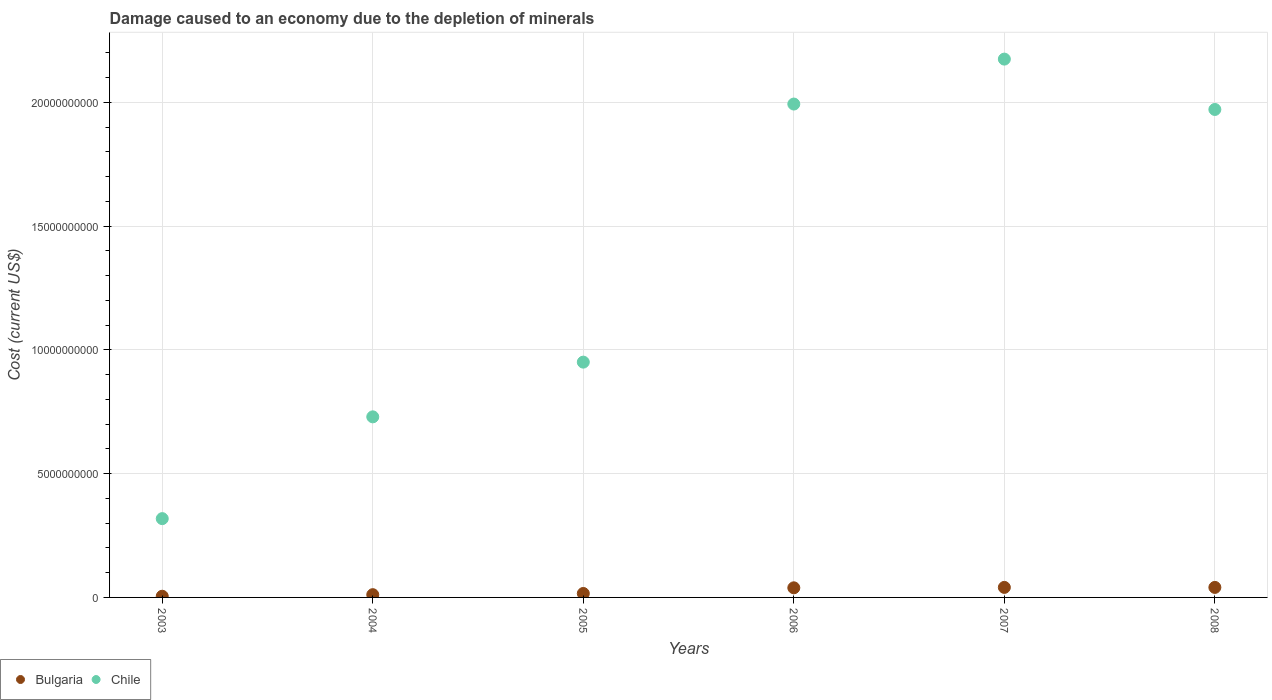Is the number of dotlines equal to the number of legend labels?
Give a very brief answer. Yes. What is the cost of damage caused due to the depletion of minerals in Bulgaria in 2006?
Provide a succinct answer. 3.88e+08. Across all years, what is the maximum cost of damage caused due to the depletion of minerals in Chile?
Provide a succinct answer. 2.18e+1. Across all years, what is the minimum cost of damage caused due to the depletion of minerals in Bulgaria?
Offer a terse response. 4.79e+07. In which year was the cost of damage caused due to the depletion of minerals in Chile minimum?
Keep it short and to the point. 2003. What is the total cost of damage caused due to the depletion of minerals in Bulgaria in the graph?
Your answer should be very brief. 1.52e+09. What is the difference between the cost of damage caused due to the depletion of minerals in Chile in 2004 and that in 2006?
Ensure brevity in your answer.  -1.26e+1. What is the difference between the cost of damage caused due to the depletion of minerals in Bulgaria in 2003 and the cost of damage caused due to the depletion of minerals in Chile in 2007?
Keep it short and to the point. -2.17e+1. What is the average cost of damage caused due to the depletion of minerals in Chile per year?
Your response must be concise. 1.36e+1. In the year 2007, what is the difference between the cost of damage caused due to the depletion of minerals in Bulgaria and cost of damage caused due to the depletion of minerals in Chile?
Provide a short and direct response. -2.13e+1. In how many years, is the cost of damage caused due to the depletion of minerals in Chile greater than 10000000000 US$?
Your answer should be very brief. 3. What is the ratio of the cost of damage caused due to the depletion of minerals in Chile in 2005 to that in 2006?
Give a very brief answer. 0.48. Is the cost of damage caused due to the depletion of minerals in Bulgaria in 2006 less than that in 2008?
Your response must be concise. Yes. What is the difference between the highest and the second highest cost of damage caused due to the depletion of minerals in Chile?
Keep it short and to the point. 1.82e+09. What is the difference between the highest and the lowest cost of damage caused due to the depletion of minerals in Chile?
Your answer should be very brief. 1.86e+1. In how many years, is the cost of damage caused due to the depletion of minerals in Bulgaria greater than the average cost of damage caused due to the depletion of minerals in Bulgaria taken over all years?
Your answer should be very brief. 3. Is the sum of the cost of damage caused due to the depletion of minerals in Bulgaria in 2003 and 2005 greater than the maximum cost of damage caused due to the depletion of minerals in Chile across all years?
Your response must be concise. No. What is the difference between two consecutive major ticks on the Y-axis?
Give a very brief answer. 5.00e+09. Are the values on the major ticks of Y-axis written in scientific E-notation?
Your answer should be compact. No. Does the graph contain any zero values?
Provide a short and direct response. No. Does the graph contain grids?
Your answer should be compact. Yes. Where does the legend appear in the graph?
Your response must be concise. Bottom left. How are the legend labels stacked?
Offer a very short reply. Horizontal. What is the title of the graph?
Your answer should be very brief. Damage caused to an economy due to the depletion of minerals. What is the label or title of the Y-axis?
Provide a succinct answer. Cost (current US$). What is the Cost (current US$) of Bulgaria in 2003?
Give a very brief answer. 4.79e+07. What is the Cost (current US$) of Chile in 2003?
Provide a short and direct response. 3.18e+09. What is the Cost (current US$) of Bulgaria in 2004?
Offer a terse response. 1.11e+08. What is the Cost (current US$) of Chile in 2004?
Offer a very short reply. 7.30e+09. What is the Cost (current US$) in Bulgaria in 2005?
Provide a succinct answer. 1.59e+08. What is the Cost (current US$) of Chile in 2005?
Provide a succinct answer. 9.51e+09. What is the Cost (current US$) of Bulgaria in 2006?
Provide a short and direct response. 3.88e+08. What is the Cost (current US$) in Chile in 2006?
Offer a very short reply. 1.99e+1. What is the Cost (current US$) of Bulgaria in 2007?
Ensure brevity in your answer.  4.05e+08. What is the Cost (current US$) in Chile in 2007?
Provide a short and direct response. 2.18e+1. What is the Cost (current US$) of Bulgaria in 2008?
Offer a terse response. 4.05e+08. What is the Cost (current US$) of Chile in 2008?
Your response must be concise. 1.97e+1. Across all years, what is the maximum Cost (current US$) in Bulgaria?
Offer a very short reply. 4.05e+08. Across all years, what is the maximum Cost (current US$) of Chile?
Offer a terse response. 2.18e+1. Across all years, what is the minimum Cost (current US$) in Bulgaria?
Provide a succinct answer. 4.79e+07. Across all years, what is the minimum Cost (current US$) in Chile?
Offer a terse response. 3.18e+09. What is the total Cost (current US$) in Bulgaria in the graph?
Keep it short and to the point. 1.52e+09. What is the total Cost (current US$) in Chile in the graph?
Offer a terse response. 8.14e+1. What is the difference between the Cost (current US$) of Bulgaria in 2003 and that in 2004?
Offer a very short reply. -6.30e+07. What is the difference between the Cost (current US$) in Chile in 2003 and that in 2004?
Provide a short and direct response. -4.11e+09. What is the difference between the Cost (current US$) of Bulgaria in 2003 and that in 2005?
Keep it short and to the point. -1.12e+08. What is the difference between the Cost (current US$) in Chile in 2003 and that in 2005?
Keep it short and to the point. -6.32e+09. What is the difference between the Cost (current US$) in Bulgaria in 2003 and that in 2006?
Give a very brief answer. -3.40e+08. What is the difference between the Cost (current US$) of Chile in 2003 and that in 2006?
Keep it short and to the point. -1.68e+1. What is the difference between the Cost (current US$) in Bulgaria in 2003 and that in 2007?
Make the answer very short. -3.57e+08. What is the difference between the Cost (current US$) of Chile in 2003 and that in 2007?
Provide a short and direct response. -1.86e+1. What is the difference between the Cost (current US$) of Bulgaria in 2003 and that in 2008?
Keep it short and to the point. -3.57e+08. What is the difference between the Cost (current US$) of Chile in 2003 and that in 2008?
Your response must be concise. -1.65e+1. What is the difference between the Cost (current US$) of Bulgaria in 2004 and that in 2005?
Give a very brief answer. -4.86e+07. What is the difference between the Cost (current US$) of Chile in 2004 and that in 2005?
Give a very brief answer. -2.21e+09. What is the difference between the Cost (current US$) in Bulgaria in 2004 and that in 2006?
Provide a short and direct response. -2.77e+08. What is the difference between the Cost (current US$) in Chile in 2004 and that in 2006?
Provide a succinct answer. -1.26e+1. What is the difference between the Cost (current US$) of Bulgaria in 2004 and that in 2007?
Your answer should be compact. -2.94e+08. What is the difference between the Cost (current US$) in Chile in 2004 and that in 2007?
Make the answer very short. -1.45e+1. What is the difference between the Cost (current US$) of Bulgaria in 2004 and that in 2008?
Your answer should be compact. -2.94e+08. What is the difference between the Cost (current US$) of Chile in 2004 and that in 2008?
Offer a terse response. -1.24e+1. What is the difference between the Cost (current US$) in Bulgaria in 2005 and that in 2006?
Provide a short and direct response. -2.29e+08. What is the difference between the Cost (current US$) in Chile in 2005 and that in 2006?
Make the answer very short. -1.04e+1. What is the difference between the Cost (current US$) of Bulgaria in 2005 and that in 2007?
Your answer should be compact. -2.46e+08. What is the difference between the Cost (current US$) of Chile in 2005 and that in 2007?
Make the answer very short. -1.22e+1. What is the difference between the Cost (current US$) in Bulgaria in 2005 and that in 2008?
Make the answer very short. -2.45e+08. What is the difference between the Cost (current US$) in Chile in 2005 and that in 2008?
Ensure brevity in your answer.  -1.02e+1. What is the difference between the Cost (current US$) of Bulgaria in 2006 and that in 2007?
Ensure brevity in your answer.  -1.68e+07. What is the difference between the Cost (current US$) in Chile in 2006 and that in 2007?
Provide a short and direct response. -1.82e+09. What is the difference between the Cost (current US$) in Bulgaria in 2006 and that in 2008?
Ensure brevity in your answer.  -1.62e+07. What is the difference between the Cost (current US$) of Chile in 2006 and that in 2008?
Offer a terse response. 2.19e+08. What is the difference between the Cost (current US$) of Bulgaria in 2007 and that in 2008?
Your answer should be very brief. 6.06e+05. What is the difference between the Cost (current US$) of Chile in 2007 and that in 2008?
Ensure brevity in your answer.  2.03e+09. What is the difference between the Cost (current US$) of Bulgaria in 2003 and the Cost (current US$) of Chile in 2004?
Make the answer very short. -7.25e+09. What is the difference between the Cost (current US$) in Bulgaria in 2003 and the Cost (current US$) in Chile in 2005?
Keep it short and to the point. -9.46e+09. What is the difference between the Cost (current US$) in Bulgaria in 2003 and the Cost (current US$) in Chile in 2006?
Your answer should be compact. -1.99e+1. What is the difference between the Cost (current US$) in Bulgaria in 2003 and the Cost (current US$) in Chile in 2007?
Make the answer very short. -2.17e+1. What is the difference between the Cost (current US$) of Bulgaria in 2003 and the Cost (current US$) of Chile in 2008?
Provide a succinct answer. -1.97e+1. What is the difference between the Cost (current US$) in Bulgaria in 2004 and the Cost (current US$) in Chile in 2005?
Ensure brevity in your answer.  -9.40e+09. What is the difference between the Cost (current US$) in Bulgaria in 2004 and the Cost (current US$) in Chile in 2006?
Make the answer very short. -1.98e+1. What is the difference between the Cost (current US$) in Bulgaria in 2004 and the Cost (current US$) in Chile in 2007?
Make the answer very short. -2.16e+1. What is the difference between the Cost (current US$) of Bulgaria in 2004 and the Cost (current US$) of Chile in 2008?
Make the answer very short. -1.96e+1. What is the difference between the Cost (current US$) in Bulgaria in 2005 and the Cost (current US$) in Chile in 2006?
Make the answer very short. -1.98e+1. What is the difference between the Cost (current US$) in Bulgaria in 2005 and the Cost (current US$) in Chile in 2007?
Offer a very short reply. -2.16e+1. What is the difference between the Cost (current US$) in Bulgaria in 2005 and the Cost (current US$) in Chile in 2008?
Provide a short and direct response. -1.96e+1. What is the difference between the Cost (current US$) in Bulgaria in 2006 and the Cost (current US$) in Chile in 2007?
Your answer should be compact. -2.14e+1. What is the difference between the Cost (current US$) of Bulgaria in 2006 and the Cost (current US$) of Chile in 2008?
Your answer should be compact. -1.93e+1. What is the difference between the Cost (current US$) in Bulgaria in 2007 and the Cost (current US$) in Chile in 2008?
Ensure brevity in your answer.  -1.93e+1. What is the average Cost (current US$) of Bulgaria per year?
Make the answer very short. 2.53e+08. What is the average Cost (current US$) in Chile per year?
Keep it short and to the point. 1.36e+1. In the year 2003, what is the difference between the Cost (current US$) in Bulgaria and Cost (current US$) in Chile?
Provide a succinct answer. -3.14e+09. In the year 2004, what is the difference between the Cost (current US$) of Bulgaria and Cost (current US$) of Chile?
Give a very brief answer. -7.19e+09. In the year 2005, what is the difference between the Cost (current US$) of Bulgaria and Cost (current US$) of Chile?
Ensure brevity in your answer.  -9.35e+09. In the year 2006, what is the difference between the Cost (current US$) of Bulgaria and Cost (current US$) of Chile?
Your response must be concise. -1.95e+1. In the year 2007, what is the difference between the Cost (current US$) of Bulgaria and Cost (current US$) of Chile?
Ensure brevity in your answer.  -2.13e+1. In the year 2008, what is the difference between the Cost (current US$) in Bulgaria and Cost (current US$) in Chile?
Make the answer very short. -1.93e+1. What is the ratio of the Cost (current US$) of Bulgaria in 2003 to that in 2004?
Make the answer very short. 0.43. What is the ratio of the Cost (current US$) of Chile in 2003 to that in 2004?
Provide a short and direct response. 0.44. What is the ratio of the Cost (current US$) in Bulgaria in 2003 to that in 2005?
Give a very brief answer. 0.3. What is the ratio of the Cost (current US$) of Chile in 2003 to that in 2005?
Give a very brief answer. 0.33. What is the ratio of the Cost (current US$) of Bulgaria in 2003 to that in 2006?
Offer a very short reply. 0.12. What is the ratio of the Cost (current US$) in Chile in 2003 to that in 2006?
Give a very brief answer. 0.16. What is the ratio of the Cost (current US$) in Bulgaria in 2003 to that in 2007?
Keep it short and to the point. 0.12. What is the ratio of the Cost (current US$) of Chile in 2003 to that in 2007?
Offer a very short reply. 0.15. What is the ratio of the Cost (current US$) of Bulgaria in 2003 to that in 2008?
Give a very brief answer. 0.12. What is the ratio of the Cost (current US$) in Chile in 2003 to that in 2008?
Give a very brief answer. 0.16. What is the ratio of the Cost (current US$) of Bulgaria in 2004 to that in 2005?
Offer a very short reply. 0.7. What is the ratio of the Cost (current US$) of Chile in 2004 to that in 2005?
Offer a terse response. 0.77. What is the ratio of the Cost (current US$) in Bulgaria in 2004 to that in 2006?
Make the answer very short. 0.29. What is the ratio of the Cost (current US$) in Chile in 2004 to that in 2006?
Give a very brief answer. 0.37. What is the ratio of the Cost (current US$) of Bulgaria in 2004 to that in 2007?
Provide a short and direct response. 0.27. What is the ratio of the Cost (current US$) of Chile in 2004 to that in 2007?
Make the answer very short. 0.34. What is the ratio of the Cost (current US$) of Bulgaria in 2004 to that in 2008?
Provide a short and direct response. 0.27. What is the ratio of the Cost (current US$) of Chile in 2004 to that in 2008?
Provide a succinct answer. 0.37. What is the ratio of the Cost (current US$) of Bulgaria in 2005 to that in 2006?
Provide a succinct answer. 0.41. What is the ratio of the Cost (current US$) in Chile in 2005 to that in 2006?
Ensure brevity in your answer.  0.48. What is the ratio of the Cost (current US$) of Bulgaria in 2005 to that in 2007?
Ensure brevity in your answer.  0.39. What is the ratio of the Cost (current US$) of Chile in 2005 to that in 2007?
Ensure brevity in your answer.  0.44. What is the ratio of the Cost (current US$) of Bulgaria in 2005 to that in 2008?
Provide a short and direct response. 0.39. What is the ratio of the Cost (current US$) of Chile in 2005 to that in 2008?
Provide a short and direct response. 0.48. What is the ratio of the Cost (current US$) of Bulgaria in 2006 to that in 2007?
Your response must be concise. 0.96. What is the ratio of the Cost (current US$) of Chile in 2006 to that in 2007?
Offer a very short reply. 0.92. What is the ratio of the Cost (current US$) in Bulgaria in 2006 to that in 2008?
Provide a short and direct response. 0.96. What is the ratio of the Cost (current US$) in Chile in 2006 to that in 2008?
Offer a very short reply. 1.01. What is the ratio of the Cost (current US$) of Chile in 2007 to that in 2008?
Give a very brief answer. 1.1. What is the difference between the highest and the second highest Cost (current US$) of Bulgaria?
Offer a terse response. 6.06e+05. What is the difference between the highest and the second highest Cost (current US$) in Chile?
Your answer should be compact. 1.82e+09. What is the difference between the highest and the lowest Cost (current US$) in Bulgaria?
Make the answer very short. 3.57e+08. What is the difference between the highest and the lowest Cost (current US$) in Chile?
Your answer should be very brief. 1.86e+1. 